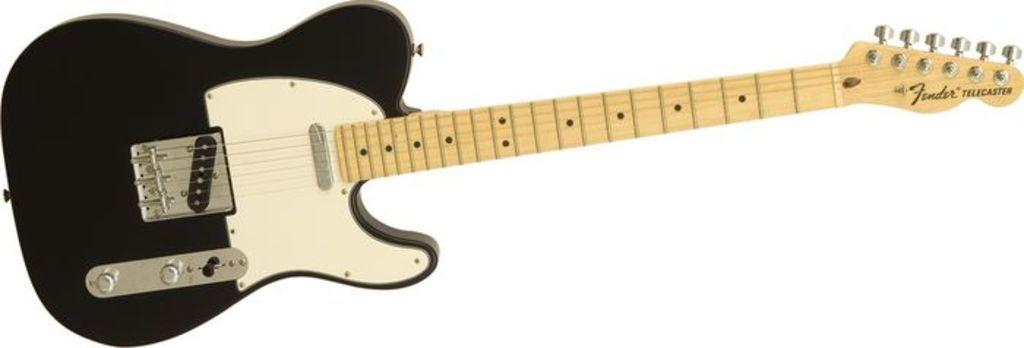What musical instrument is present in the image? There is a guitar in the image. What colors can be seen on the guitar? The guitar is black and yellow in color. How many clovers are growing around the guitar in the image? There are no clovers present in the image; it only features a guitar. What type of fruit is hanging from the guitar in the image? There is no fruit, such as a quince, hanging from the guitar in the image. 